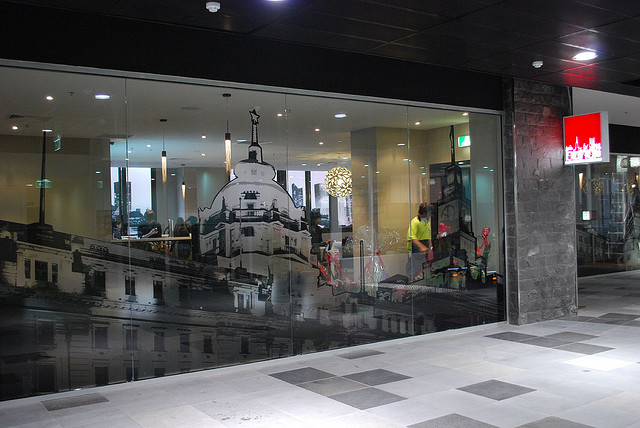<image>Which store is this? I don't know which store this is. It could be "Macy's", "fordis", "enyce", "ecko", or a clothing store in a mall. Which store is this? I don't know which store is this. It could be 'macy's', 'museum', 'fordis', 'building', 'mall', 'enyce', 'ecko', or 'clothing'. 